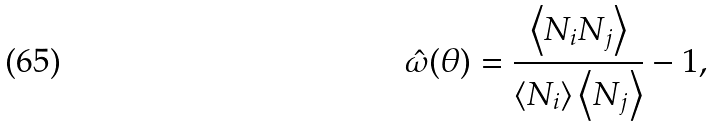<formula> <loc_0><loc_0><loc_500><loc_500>\hat { \omega } ( \theta ) = \frac { \left < N _ { i } N _ { j } \right > } { \left < N _ { i } \right > \left < N _ { j } \right > } - 1 ,</formula> 